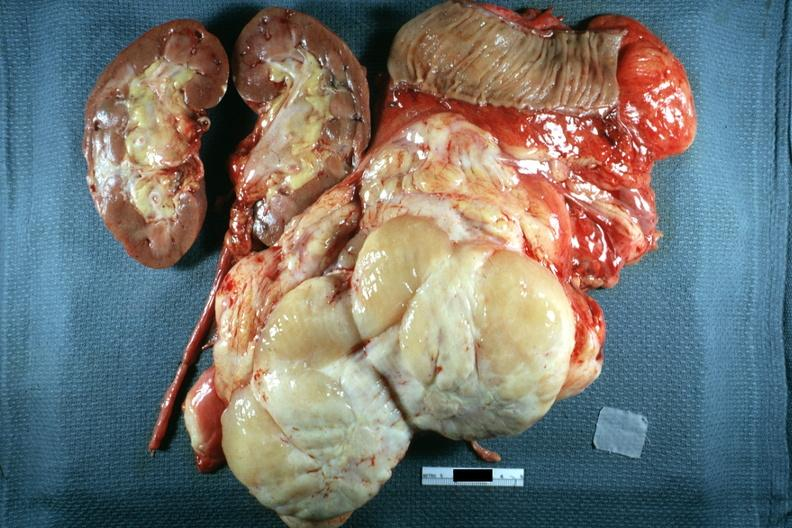what is present?
Answer the question using a single word or phrase. Retroperitoneal liposarcoma 